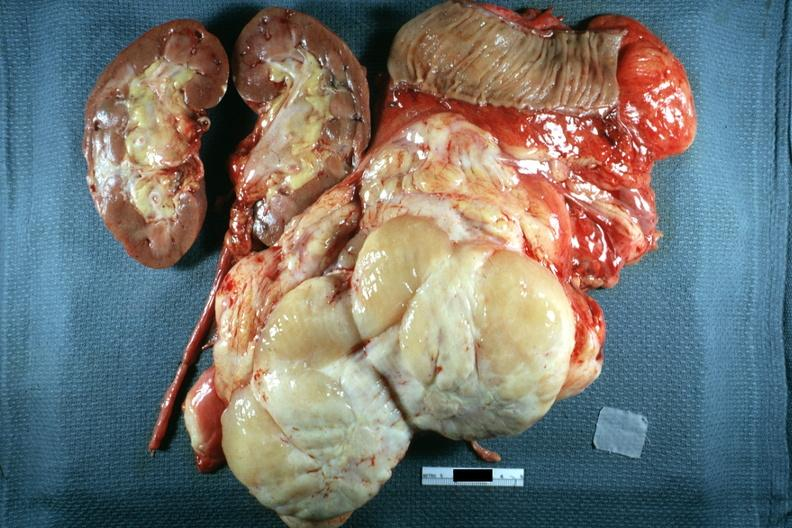what is present?
Answer the question using a single word or phrase. Retroperitoneal liposarcoma 